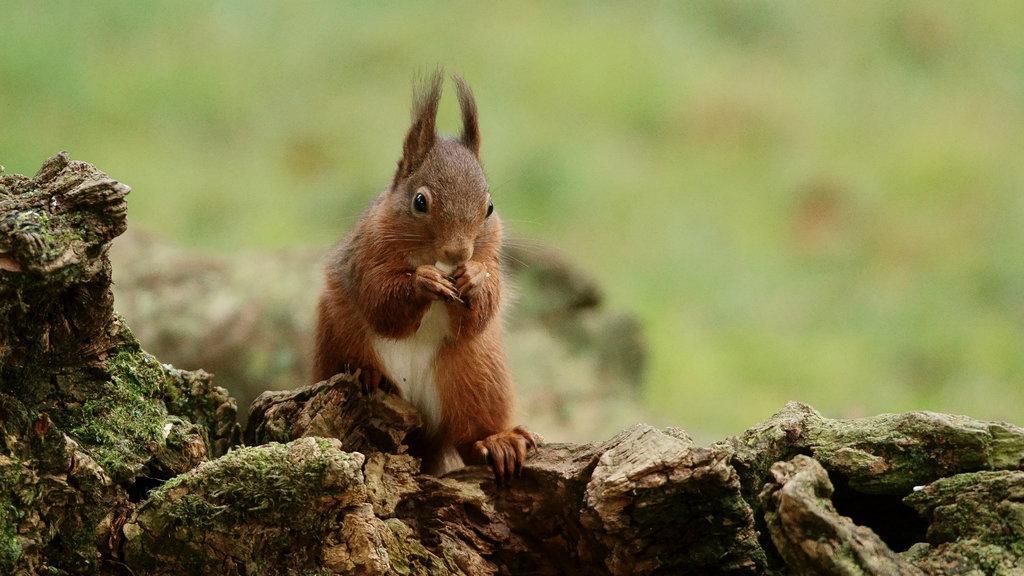How would you summarize this image in a sentence or two? In this image we can see a squirrel sitting on the branch. 